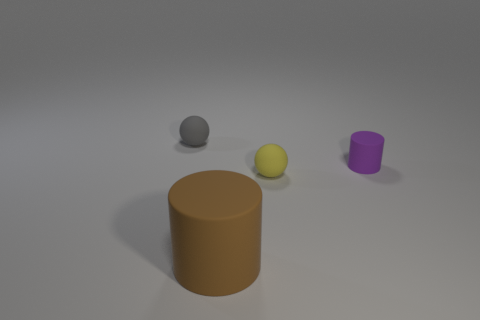Are there any other things that have the same size as the brown rubber cylinder?
Your response must be concise. No. Is the material of the small ball that is on the left side of the brown matte thing the same as the small yellow ball?
Give a very brief answer. Yes. What number of spheres are purple rubber things or gray rubber things?
Give a very brief answer. 1. There is a matte object that is left of the yellow sphere and behind the large brown cylinder; what shape is it?
Your answer should be very brief. Sphere. The small ball that is behind the small thing that is right of the ball that is right of the brown rubber object is what color?
Your answer should be very brief. Gray. Are there fewer large matte things in front of the gray matte ball than tiny things?
Keep it short and to the point. Yes. Is the shape of the yellow object that is to the right of the brown matte cylinder the same as the tiny rubber object to the left of the brown matte cylinder?
Make the answer very short. Yes. How many objects are gray balls to the left of the big brown object or small things?
Offer a terse response. 3. Is there a rubber object that is behind the sphere in front of the gray object on the left side of the small purple object?
Offer a very short reply. Yes. Is the number of cylinders that are right of the small purple matte cylinder less than the number of objects to the right of the brown rubber cylinder?
Your response must be concise. Yes. 